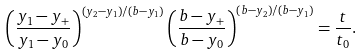Convert formula to latex. <formula><loc_0><loc_0><loc_500><loc_500>\left ( \frac { y _ { 1 } - y _ { + } } { y _ { 1 } - y _ { 0 } } \right ) ^ { ( y _ { 2 } - y _ { 1 } ) / ( b - y _ { 1 } ) } \left ( \frac { b - y _ { + } } { b - y _ { 0 } } \right ) ^ { ( b - y _ { 2 } ) / ( b - y _ { 1 } ) } = \frac { t } { t _ { 0 } } .</formula> 